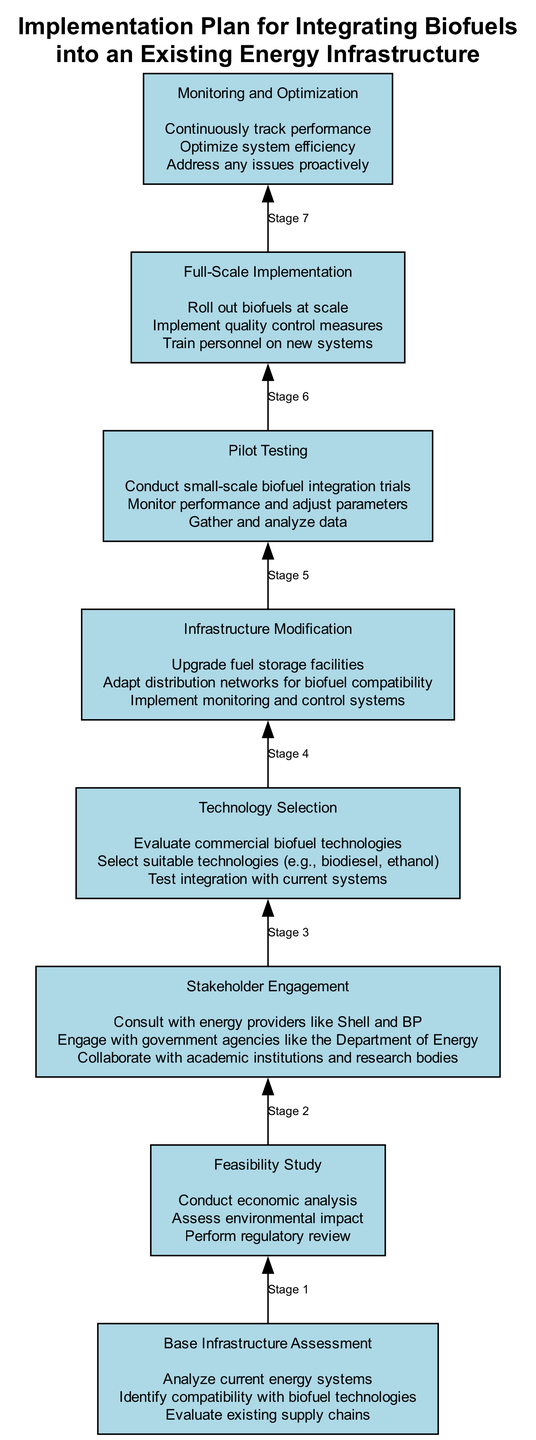What is the last stage in the flow chart? The last stage, which is located at the top of the diagram, is "Monitoring and Optimization". There are no other nodes above it, indicating it is the final step.
Answer: Monitoring and Optimization How many actions are listed under "Technology Selection"? The "Technology Selection" stage has three actions listed below it. These actions can be counted directly from the text at that stage.
Answer: 3 Which stage comes immediately before "Pilot Testing"? "Infrastructure Modification" is the stage that comes directly before "Pilot Testing" in the sequence of stages represented in the diagram. This relationship is indicated by the connecting edges.
Answer: Infrastructure Modification List the stakeholders mentioned in "Stakeholder Engagement". The actions listed under "Stakeholder Engagement" include consultations with energy providers, government agencies, and academic institutions. The relevant stakeholders are Shell, BP, and the Department of Energy, among others.
Answer: Shell, BP, and Department of Energy What action is first in the "Feasibility Study" stage? The first action in the "Feasibility Study" stage is "Conduct economic analysis." This can be determined by examining the list of actions under that stage.
Answer: Conduct economic analysis What is the purpose of the "Pilot Testing" stage? The purpose of the "Pilot Testing" stage involves conducting small-scale trials to see how biofuels can integrate into the system. This purpose is inferred from the actions described in that stage, which focus on testing and monitoring performance.
Answer: Conduct small-scale biofuel integration trials Which two stages focus on technology evaluation? The stages "Technology Selection" and "Feasibility Study" both involve evaluating technologies, with "Technology Selection" focusing on commercial biofuel technologies and "Feasibility Study" assessing broader considerations, including technology compatibility.
Answer: Technology Selection and Feasibility Study 